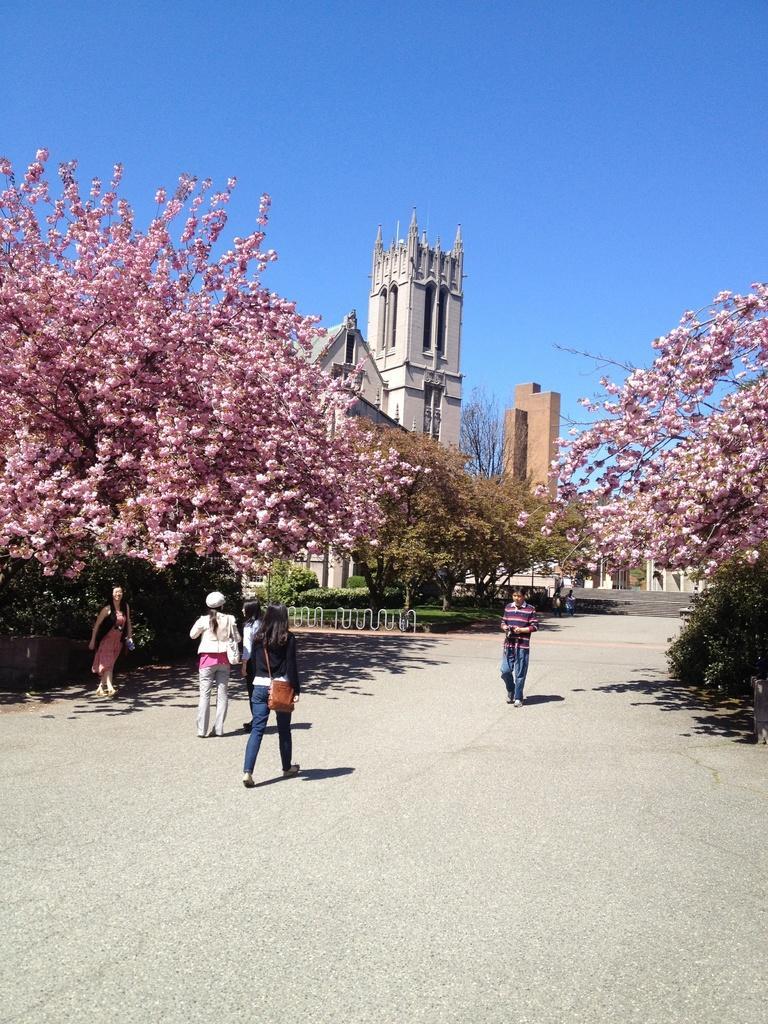Could you give a brief overview of what you see in this image? In this picture we can see five persons are walking, on the left side and right side there are trees, in the background we can see buildings, grass and trees, there is the sky at the top of the picture. 